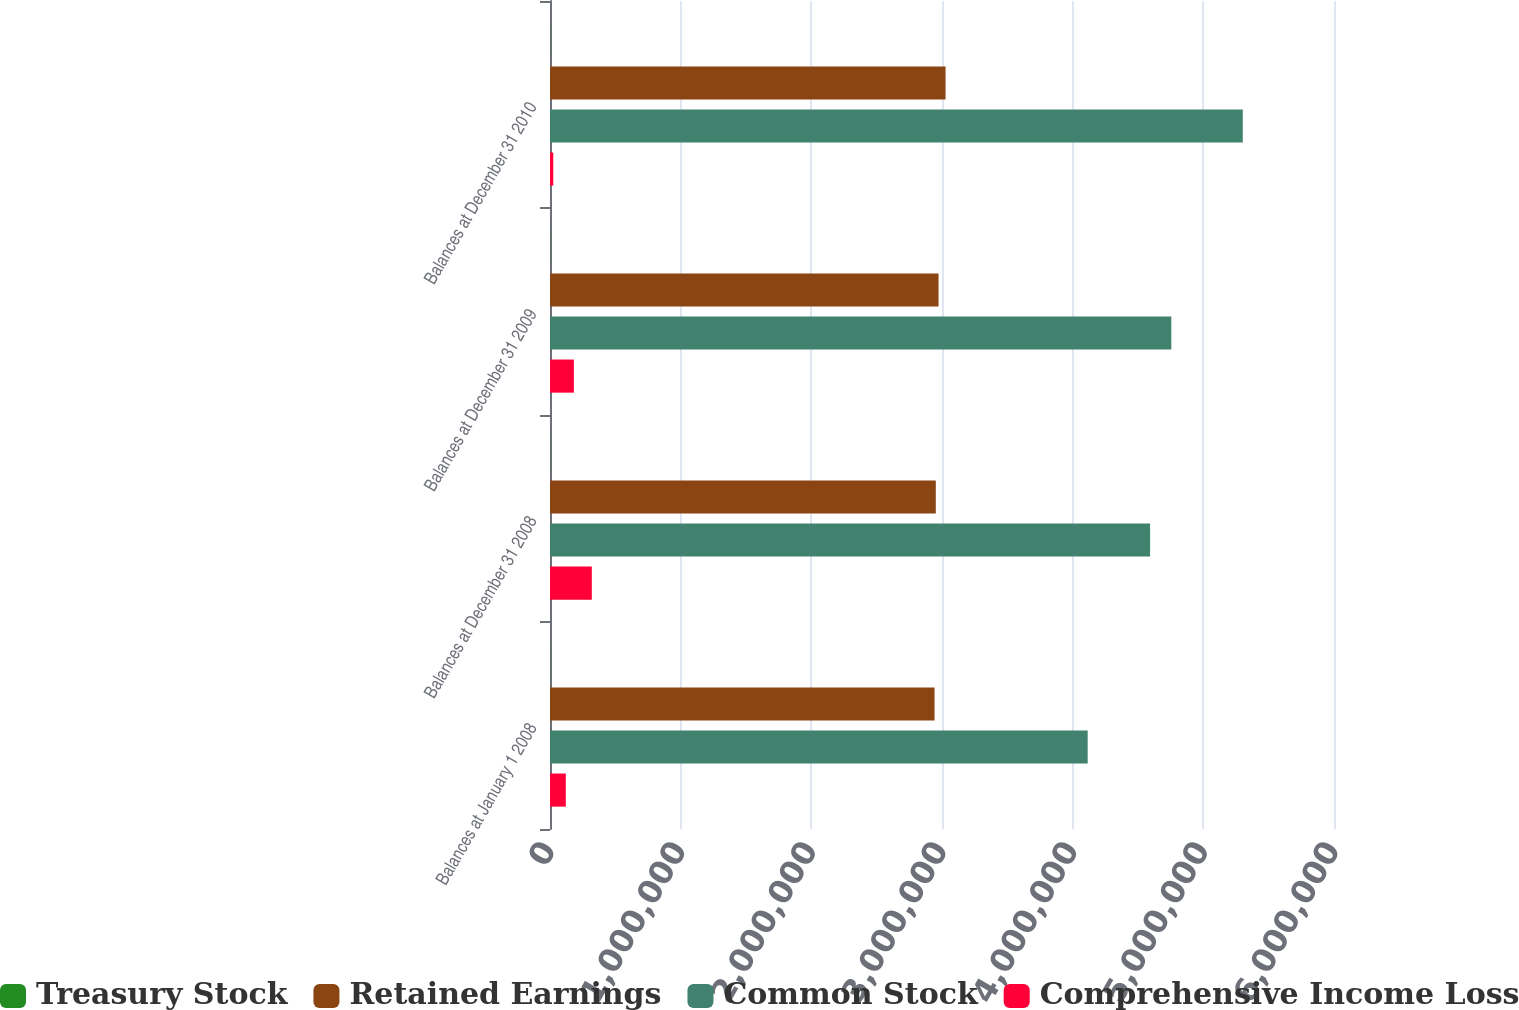Convert chart to OTSL. <chart><loc_0><loc_0><loc_500><loc_500><stacked_bar_chart><ecel><fcel>Balances at January 1 2008<fcel>Balances at December 31 2008<fcel>Balances at December 31 2009<fcel>Balances at December 31 2010<nl><fcel>Treasury Stock<fcel>2235<fcel>2239<fcel>2243<fcel>2262<nl><fcel>Retained Earnings<fcel>2.94294e+06<fcel>2.95254e+06<fcel>2.9735e+06<fcel>3.02713e+06<nl><fcel>Common Stock<fcel>4.11488e+06<fcel>4.59253e+06<fcel>4.75495e+06<fcel>5.30175e+06<nl><fcel>Comprehensive Income Loss<fcel>120955<fcel>319936<fcel>182733<fcel>25066<nl></chart> 